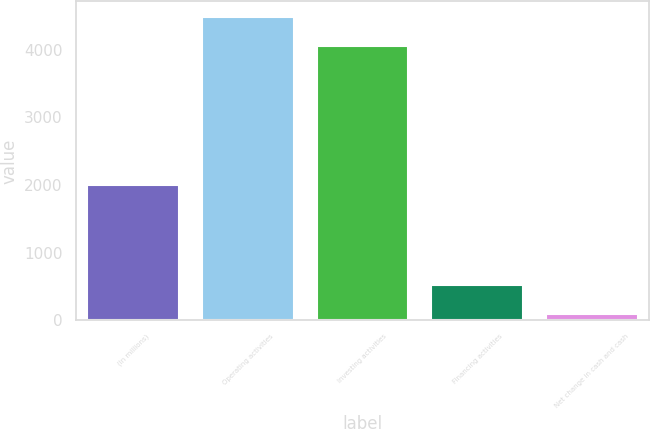Convert chart. <chart><loc_0><loc_0><loc_500><loc_500><bar_chart><fcel>(In millions)<fcel>Operating activities<fcel>Investing activities<fcel>Financing activities<fcel>Net change in cash and cash<nl><fcel>2006<fcel>4487.3<fcel>4057<fcel>524.3<fcel>94<nl></chart> 